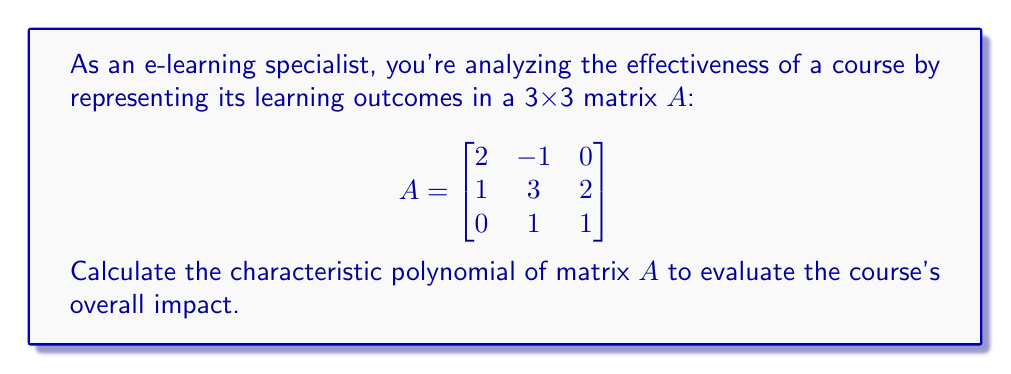Provide a solution to this math problem. To find the characteristic polynomial of matrix A, we follow these steps:

1) The characteristic polynomial is defined as $p(λ) = det(λI - A)$, where I is the 3x3 identity matrix.

2) Let's calculate $λI - A$:

   $$λI - A = \begin{bmatrix}
   λ & 0 & 0 \\
   0 & λ & 0 \\
   0 & 0 & λ
   \end{bmatrix} - \begin{bmatrix}
   2 & -1 & 0 \\
   1 & 3 & 2 \\
   0 & 1 & 1
   \end{bmatrix} = \begin{bmatrix}
   λ-2 & 1 & 0 \\
   -1 & λ-3 & -2 \\
   0 & -1 & λ-1
   \end{bmatrix}$$

3) Now, we need to calculate the determinant of this matrix:

   $det(λI - A) = (λ-2)[(λ-3)(λ-1) - 2] + 1[(λ-1) - 0] + 0$

4) Expanding this:
   
   $= (λ-2)(λ^2 - 4λ + 3 - 2) + (λ-1)$
   $= (λ-2)(λ^2 - 4λ + 1) + λ - 1$
   $= λ^3 - 4λ^2 + λ - 2λ^2 + 8λ - 2 + λ - 1$
   $= λ^3 - 6λ^2 + 10λ - 3$

5) Therefore, the characteristic polynomial is:

   $p(λ) = λ^3 - 6λ^2 + 10λ - 3$

This polynomial can be used to analyze the eigenvalues of the matrix, which represent the key factors influencing the learning outcomes.
Answer: $p(λ) = λ^3 - 6λ^2 + 10λ - 3$ 